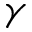<formula> <loc_0><loc_0><loc_500><loc_500>\gamma</formula> 